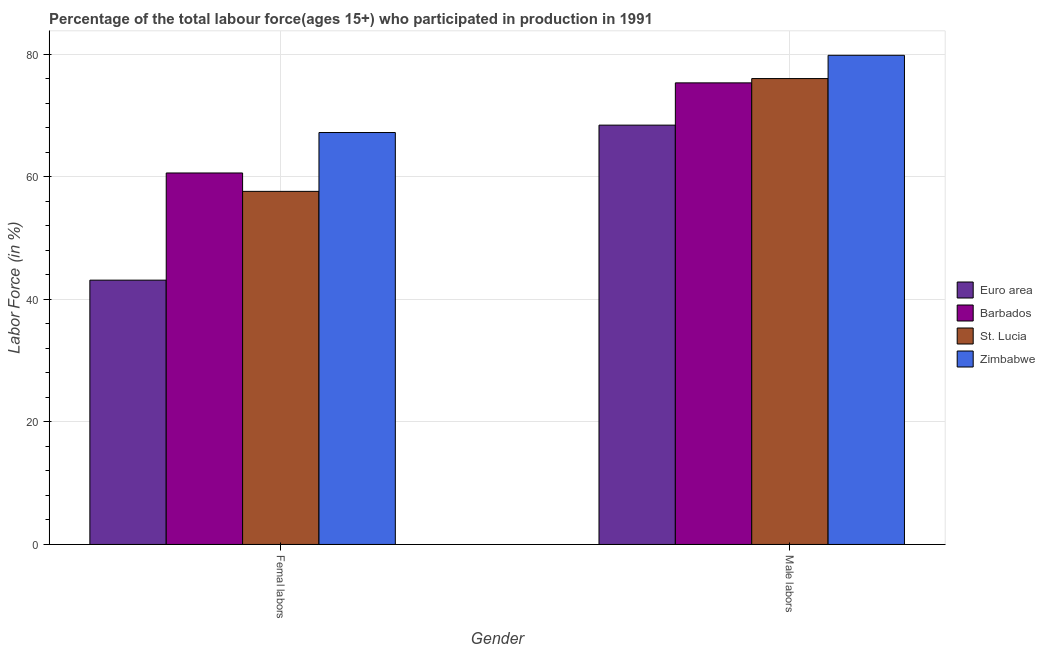How many different coloured bars are there?
Offer a very short reply. 4. How many groups of bars are there?
Give a very brief answer. 2. Are the number of bars on each tick of the X-axis equal?
Ensure brevity in your answer.  Yes. How many bars are there on the 2nd tick from the left?
Make the answer very short. 4. How many bars are there on the 2nd tick from the right?
Your answer should be very brief. 4. What is the label of the 2nd group of bars from the left?
Offer a terse response. Male labors. What is the percentage of female labor force in Barbados?
Provide a succinct answer. 60.6. Across all countries, what is the maximum percentage of female labor force?
Provide a short and direct response. 67.2. Across all countries, what is the minimum percentage of male labour force?
Offer a terse response. 68.4. In which country was the percentage of female labor force maximum?
Your answer should be compact. Zimbabwe. In which country was the percentage of female labor force minimum?
Keep it short and to the point. Euro area. What is the total percentage of male labour force in the graph?
Your response must be concise. 299.5. What is the difference between the percentage of male labour force in Euro area and that in Zimbabwe?
Provide a short and direct response. -11.4. What is the difference between the percentage of male labour force in Barbados and the percentage of female labor force in St. Lucia?
Offer a terse response. 17.7. What is the average percentage of male labour force per country?
Your response must be concise. 74.88. What is the difference between the percentage of male labour force and percentage of female labor force in St. Lucia?
Your answer should be compact. 18.4. What is the ratio of the percentage of female labor force in Barbados to that in Zimbabwe?
Your answer should be very brief. 0.9. Is the percentage of male labour force in St. Lucia less than that in Barbados?
Ensure brevity in your answer.  No. In how many countries, is the percentage of male labour force greater than the average percentage of male labour force taken over all countries?
Keep it short and to the point. 3. What does the 3rd bar from the left in Femal labors represents?
Your answer should be compact. St. Lucia. What does the 1st bar from the right in Femal labors represents?
Provide a short and direct response. Zimbabwe. Are all the bars in the graph horizontal?
Provide a succinct answer. No. How many countries are there in the graph?
Provide a short and direct response. 4. What is the difference between two consecutive major ticks on the Y-axis?
Your answer should be compact. 20. Does the graph contain any zero values?
Ensure brevity in your answer.  No. Where does the legend appear in the graph?
Ensure brevity in your answer.  Center right. How many legend labels are there?
Offer a terse response. 4. What is the title of the graph?
Your answer should be very brief. Percentage of the total labour force(ages 15+) who participated in production in 1991. What is the Labor Force (in %) in Euro area in Femal labors?
Ensure brevity in your answer.  43.12. What is the Labor Force (in %) of Barbados in Femal labors?
Give a very brief answer. 60.6. What is the Labor Force (in %) of St. Lucia in Femal labors?
Offer a very short reply. 57.6. What is the Labor Force (in %) of Zimbabwe in Femal labors?
Give a very brief answer. 67.2. What is the Labor Force (in %) of Euro area in Male labors?
Make the answer very short. 68.4. What is the Labor Force (in %) in Barbados in Male labors?
Offer a terse response. 75.3. What is the Labor Force (in %) of Zimbabwe in Male labors?
Make the answer very short. 79.8. Across all Gender, what is the maximum Labor Force (in %) of Euro area?
Your answer should be very brief. 68.4. Across all Gender, what is the maximum Labor Force (in %) in Barbados?
Provide a succinct answer. 75.3. Across all Gender, what is the maximum Labor Force (in %) in St. Lucia?
Provide a succinct answer. 76. Across all Gender, what is the maximum Labor Force (in %) in Zimbabwe?
Your answer should be very brief. 79.8. Across all Gender, what is the minimum Labor Force (in %) of Euro area?
Make the answer very short. 43.12. Across all Gender, what is the minimum Labor Force (in %) of Barbados?
Your response must be concise. 60.6. Across all Gender, what is the minimum Labor Force (in %) in St. Lucia?
Offer a terse response. 57.6. Across all Gender, what is the minimum Labor Force (in %) of Zimbabwe?
Keep it short and to the point. 67.2. What is the total Labor Force (in %) in Euro area in the graph?
Your answer should be very brief. 111.52. What is the total Labor Force (in %) in Barbados in the graph?
Your answer should be compact. 135.9. What is the total Labor Force (in %) of St. Lucia in the graph?
Offer a very short reply. 133.6. What is the total Labor Force (in %) of Zimbabwe in the graph?
Keep it short and to the point. 147. What is the difference between the Labor Force (in %) of Euro area in Femal labors and that in Male labors?
Ensure brevity in your answer.  -25.29. What is the difference between the Labor Force (in %) in Barbados in Femal labors and that in Male labors?
Give a very brief answer. -14.7. What is the difference between the Labor Force (in %) in St. Lucia in Femal labors and that in Male labors?
Offer a terse response. -18.4. What is the difference between the Labor Force (in %) in Zimbabwe in Femal labors and that in Male labors?
Ensure brevity in your answer.  -12.6. What is the difference between the Labor Force (in %) in Euro area in Femal labors and the Labor Force (in %) in Barbados in Male labors?
Provide a succinct answer. -32.18. What is the difference between the Labor Force (in %) in Euro area in Femal labors and the Labor Force (in %) in St. Lucia in Male labors?
Ensure brevity in your answer.  -32.88. What is the difference between the Labor Force (in %) of Euro area in Femal labors and the Labor Force (in %) of Zimbabwe in Male labors?
Keep it short and to the point. -36.68. What is the difference between the Labor Force (in %) in Barbados in Femal labors and the Labor Force (in %) in St. Lucia in Male labors?
Ensure brevity in your answer.  -15.4. What is the difference between the Labor Force (in %) of Barbados in Femal labors and the Labor Force (in %) of Zimbabwe in Male labors?
Your response must be concise. -19.2. What is the difference between the Labor Force (in %) in St. Lucia in Femal labors and the Labor Force (in %) in Zimbabwe in Male labors?
Keep it short and to the point. -22.2. What is the average Labor Force (in %) in Euro area per Gender?
Ensure brevity in your answer.  55.76. What is the average Labor Force (in %) in Barbados per Gender?
Offer a terse response. 67.95. What is the average Labor Force (in %) of St. Lucia per Gender?
Offer a very short reply. 66.8. What is the average Labor Force (in %) of Zimbabwe per Gender?
Provide a succinct answer. 73.5. What is the difference between the Labor Force (in %) of Euro area and Labor Force (in %) of Barbados in Femal labors?
Keep it short and to the point. -17.48. What is the difference between the Labor Force (in %) of Euro area and Labor Force (in %) of St. Lucia in Femal labors?
Your answer should be very brief. -14.48. What is the difference between the Labor Force (in %) of Euro area and Labor Force (in %) of Zimbabwe in Femal labors?
Your response must be concise. -24.08. What is the difference between the Labor Force (in %) in Euro area and Labor Force (in %) in Barbados in Male labors?
Offer a terse response. -6.9. What is the difference between the Labor Force (in %) in Euro area and Labor Force (in %) in St. Lucia in Male labors?
Offer a very short reply. -7.6. What is the difference between the Labor Force (in %) of Euro area and Labor Force (in %) of Zimbabwe in Male labors?
Offer a terse response. -11.4. What is the ratio of the Labor Force (in %) of Euro area in Femal labors to that in Male labors?
Your answer should be very brief. 0.63. What is the ratio of the Labor Force (in %) in Barbados in Femal labors to that in Male labors?
Give a very brief answer. 0.8. What is the ratio of the Labor Force (in %) of St. Lucia in Femal labors to that in Male labors?
Make the answer very short. 0.76. What is the ratio of the Labor Force (in %) of Zimbabwe in Femal labors to that in Male labors?
Give a very brief answer. 0.84. What is the difference between the highest and the second highest Labor Force (in %) of Euro area?
Provide a short and direct response. 25.29. What is the difference between the highest and the second highest Labor Force (in %) in Barbados?
Offer a terse response. 14.7. What is the difference between the highest and the second highest Labor Force (in %) of St. Lucia?
Keep it short and to the point. 18.4. What is the difference between the highest and the lowest Labor Force (in %) in Euro area?
Provide a short and direct response. 25.29. What is the difference between the highest and the lowest Labor Force (in %) in Barbados?
Ensure brevity in your answer.  14.7. What is the difference between the highest and the lowest Labor Force (in %) of St. Lucia?
Offer a terse response. 18.4. 